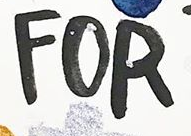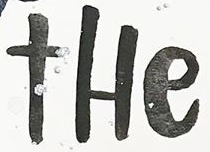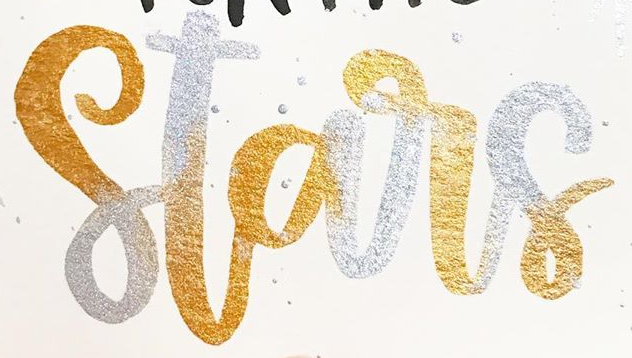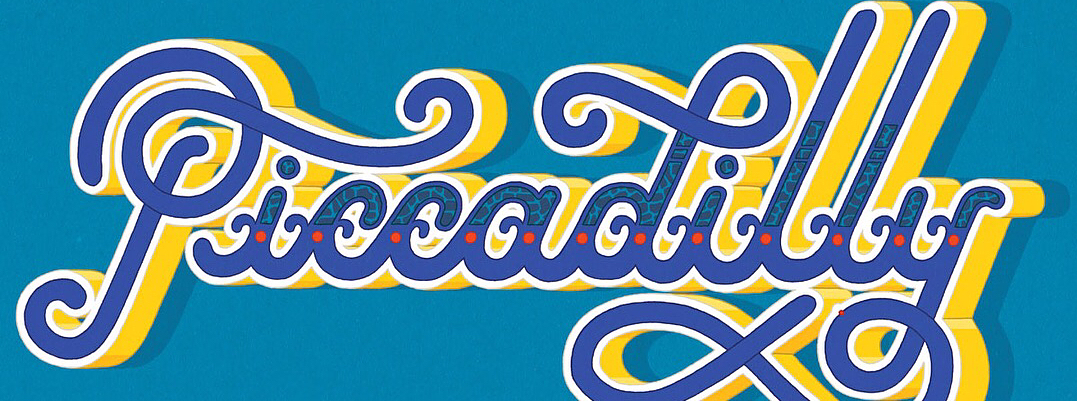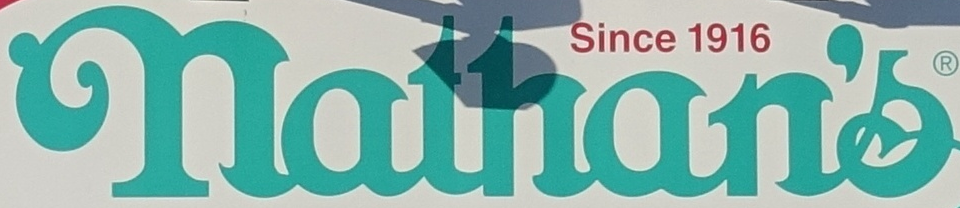What text is displayed in these images sequentially, separated by a semicolon? FOR; tHe; Stars; Piccadilly; nathan's 